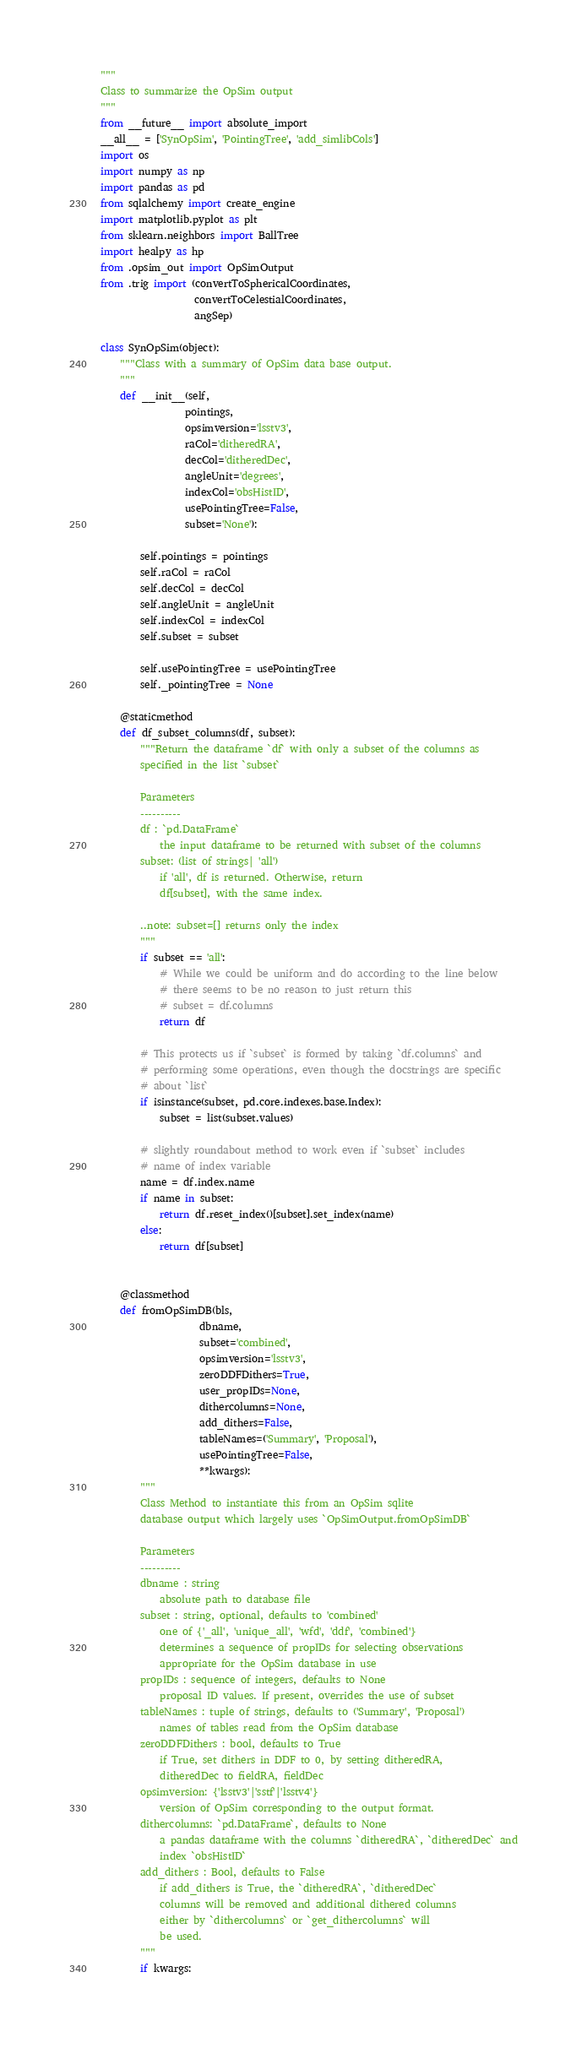Convert code to text. <code><loc_0><loc_0><loc_500><loc_500><_Python_>"""
Class to summarize the OpSim output
"""
from __future__ import absolute_import
__all__ = ['SynOpSim', 'PointingTree', 'add_simlibCols']
import os
import numpy as np
import pandas as pd
from sqlalchemy import create_engine
import matplotlib.pyplot as plt
from sklearn.neighbors import BallTree
import healpy as hp
from .opsim_out import OpSimOutput
from .trig import (convertToSphericalCoordinates,
                   convertToCelestialCoordinates,
                   angSep)

class SynOpSim(object):
    """Class with a summary of OpSim data base output.
    """
    def __init__(self,
                 pointings,
                 opsimversion='lsstv3',
                 raCol='ditheredRA',
                 decCol='ditheredDec',
                 angleUnit='degrees',
                 indexCol='obsHistID',
                 usePointingTree=False,
                 subset='None'):

        self.pointings = pointings
        self.raCol = raCol
        self.decCol = decCol
        self.angleUnit = angleUnit
        self.indexCol = indexCol
        self.subset = subset

        self.usePointingTree = usePointingTree
        self._pointingTree = None

    @staticmethod
    def df_subset_columns(df, subset):
        """Return the dataframe `df` with only a subset of the columns as
        specified in the list `subset`

        Parameters
        ----------
        df : `pd.DataFrame`
            the input dataframe to be returned with subset of the columns
        subset: (list of strings| 'all')
            if 'all', df is returned. Otherwise, return
            df[subset], with the same index.

        ..note: subset=[] returns only the index
        """
        if subset == 'all':
            # While we could be uniform and do according to the line below
            # there seems to be no reason to just return this
            # subset = df.columns
            return df

        # This protects us if `subset` is formed by taking `df.columns` and
        # performing some operations, even though the docstrings are specific
        # about `list`
        if isinstance(subset, pd.core.indexes.base.Index):
            subset = list(subset.values)

        # slightly roundabout method to work even if `subset` includes
        # name of index variable
        name = df.index.name
        if name in subset:
            return df.reset_index()[subset].set_index(name)
        else:
            return df[subset]


    @classmethod
    def fromOpSimDB(bls,
                    dbname,
                    subset='combined',
                    opsimversion='lsstv3',
                    zeroDDFDithers=True,
                    user_propIDs=None,
                    dithercolumns=None,
                    add_dithers=False,
                    tableNames=('Summary', 'Proposal'),
                    usePointingTree=False,
                    **kwargs):
        """
        Class Method to instantiate this from an OpSim sqlite
        database output which largely uses `OpSimOutput.fromOpSimDB`

        Parameters
        ----------
        dbname : string
            absolute path to database file
        subset : string, optional, defaults to 'combined'
            one of {'_all', 'unique_all', 'wfd', 'ddf', 'combined'}
            determines a sequence of propIDs for selecting observations
            appropriate for the OpSim database in use
        propIDs : sequence of integers, defaults to None
            proposal ID values. If present, overrides the use of subset
        tableNames : tuple of strings, defaults to ('Summary', 'Proposal')
            names of tables read from the OpSim database
        zeroDDFDithers : bool, defaults to True
            if True, set dithers in DDF to 0, by setting ditheredRA,
            ditheredDec to fieldRA, fieldDec
        opsimversion: {'lsstv3'|'sstf'|'lsstv4'}
            version of OpSim corresponding to the output format.
        dithercolumns: `pd.DataFrame`, defaults to None
            a pandas dataframe with the columns `ditheredRA`, `ditheredDec` and
            index `obsHistID`
        add_dithers : Bool, defaults to False
            if add_dithers is True, the `ditheredRA`, `ditheredDec`
            columns will be removed and additional dithered columns
            either by `dithercolumns` or `get_dithercolumns` will
            be used.
        """
        if kwargs:</code> 